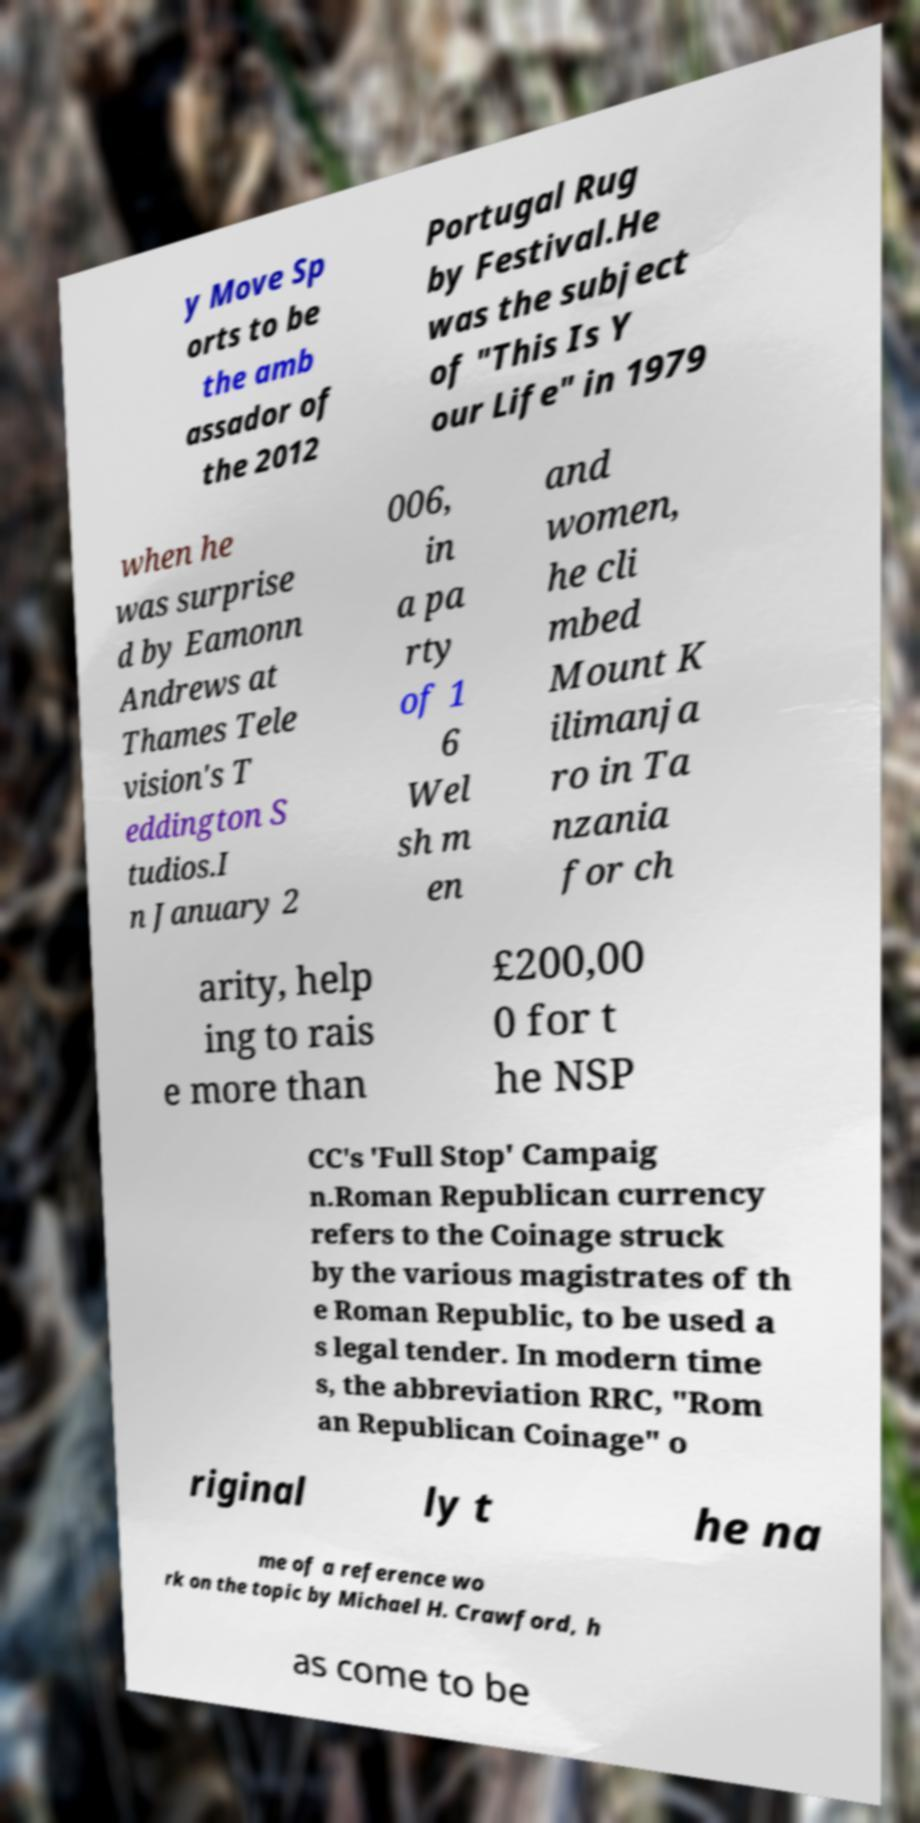Can you accurately transcribe the text from the provided image for me? y Move Sp orts to be the amb assador of the 2012 Portugal Rug by Festival.He was the subject of "This Is Y our Life" in 1979 when he was surprise d by Eamonn Andrews at Thames Tele vision's T eddington S tudios.I n January 2 006, in a pa rty of 1 6 Wel sh m en and women, he cli mbed Mount K ilimanja ro in Ta nzania for ch arity, help ing to rais e more than £200,00 0 for t he NSP CC's 'Full Stop' Campaig n.Roman Republican currency refers to the Coinage struck by the various magistrates of th e Roman Republic, to be used a s legal tender. In modern time s, the abbreviation RRC, "Rom an Republican Coinage" o riginal ly t he na me of a reference wo rk on the topic by Michael H. Crawford, h as come to be 